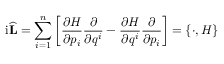<formula> <loc_0><loc_0><loc_500><loc_500>i { \widehat { L } } = \sum _ { i = 1 } ^ { n } \left [ { \frac { \partial H } { \partial p _ { i } } } { \frac { \partial } { \partial q ^ { i } } } - { \frac { \partial H } { \partial q ^ { i } } } { \frac { \partial } { \partial p _ { i } } } \right ] = \{ \cdot , H \}</formula> 